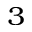<formula> <loc_0><loc_0><loc_500><loc_500>^ { 3 }</formula> 